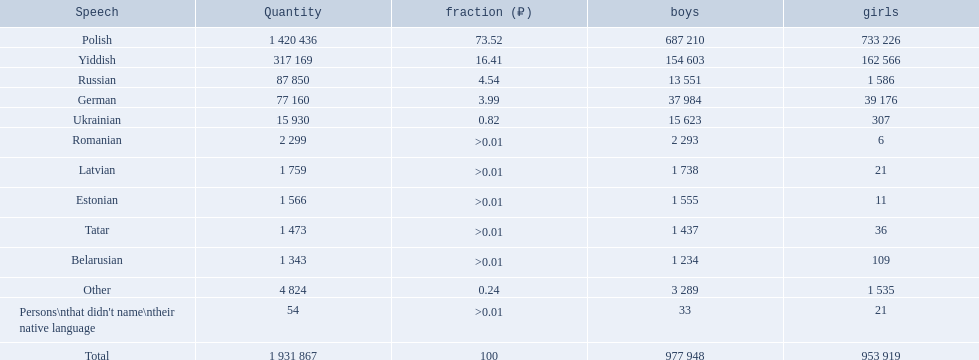Which languages had percentages of >0.01? Romanian, Latvian, Estonian, Tatar, Belarusian. What was the top language? Romanian. 